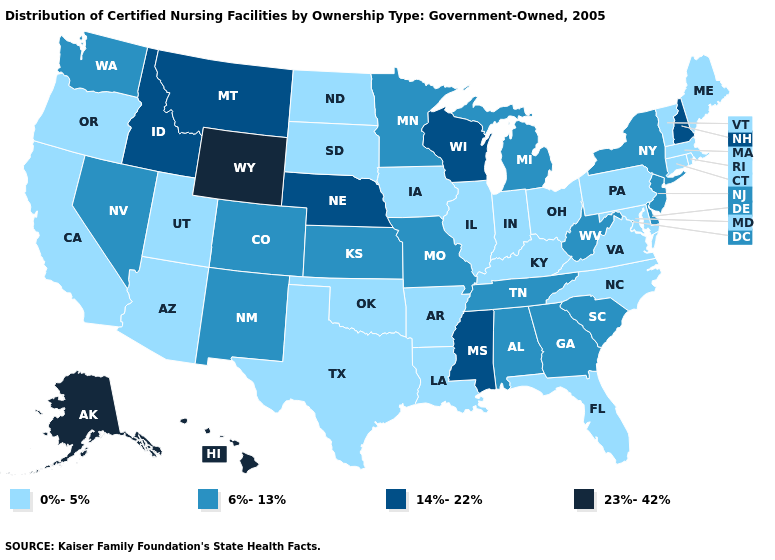What is the value of Maryland?
Answer briefly. 0%-5%. Name the states that have a value in the range 6%-13%?
Short answer required. Alabama, Colorado, Delaware, Georgia, Kansas, Michigan, Minnesota, Missouri, Nevada, New Jersey, New Mexico, New York, South Carolina, Tennessee, Washington, West Virginia. What is the value of Washington?
Concise answer only. 6%-13%. Which states have the lowest value in the USA?
Give a very brief answer. Arizona, Arkansas, California, Connecticut, Florida, Illinois, Indiana, Iowa, Kentucky, Louisiana, Maine, Maryland, Massachusetts, North Carolina, North Dakota, Ohio, Oklahoma, Oregon, Pennsylvania, Rhode Island, South Dakota, Texas, Utah, Vermont, Virginia. Is the legend a continuous bar?
Give a very brief answer. No. Name the states that have a value in the range 0%-5%?
Write a very short answer. Arizona, Arkansas, California, Connecticut, Florida, Illinois, Indiana, Iowa, Kentucky, Louisiana, Maine, Maryland, Massachusetts, North Carolina, North Dakota, Ohio, Oklahoma, Oregon, Pennsylvania, Rhode Island, South Dakota, Texas, Utah, Vermont, Virginia. What is the value of Tennessee?
Answer briefly. 6%-13%. What is the value of North Carolina?
Give a very brief answer. 0%-5%. What is the value of Alaska?
Answer briefly. 23%-42%. What is the highest value in the MidWest ?
Answer briefly. 14%-22%. Among the states that border Wyoming , does Nebraska have the highest value?
Be succinct. Yes. Does Wyoming have a lower value than Tennessee?
Write a very short answer. No. Which states hav the highest value in the West?
Answer briefly. Alaska, Hawaii, Wyoming. Does Wyoming have a higher value than Iowa?
Answer briefly. Yes. What is the value of Florida?
Quick response, please. 0%-5%. 